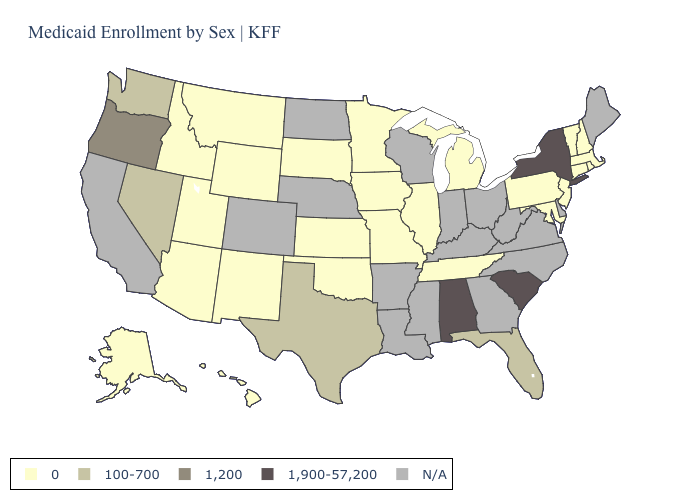Does Oregon have the lowest value in the USA?
Keep it brief. No. What is the value of Rhode Island?
Write a very short answer. 0. Among the states that border New York , which have the lowest value?
Write a very short answer. Connecticut, Massachusetts, New Jersey, Pennsylvania, Vermont. Name the states that have a value in the range 100-700?
Answer briefly. Florida, Nevada, Texas, Washington. What is the lowest value in the USA?
Quick response, please. 0. Name the states that have a value in the range N/A?
Concise answer only. Arkansas, California, Colorado, Delaware, Georgia, Indiana, Kentucky, Louisiana, Maine, Mississippi, Nebraska, North Carolina, North Dakota, Ohio, Virginia, West Virginia, Wisconsin. What is the highest value in the USA?
Short answer required. 1,900-57,200. Among the states that border Ohio , which have the highest value?
Keep it brief. Michigan, Pennsylvania. What is the value of Delaware?
Be succinct. N/A. Does the first symbol in the legend represent the smallest category?
Be succinct. Yes. Which states hav the highest value in the South?
Quick response, please. Alabama, South Carolina. Does the first symbol in the legend represent the smallest category?
Short answer required. Yes. What is the value of New York?
Be succinct. 1,900-57,200. 